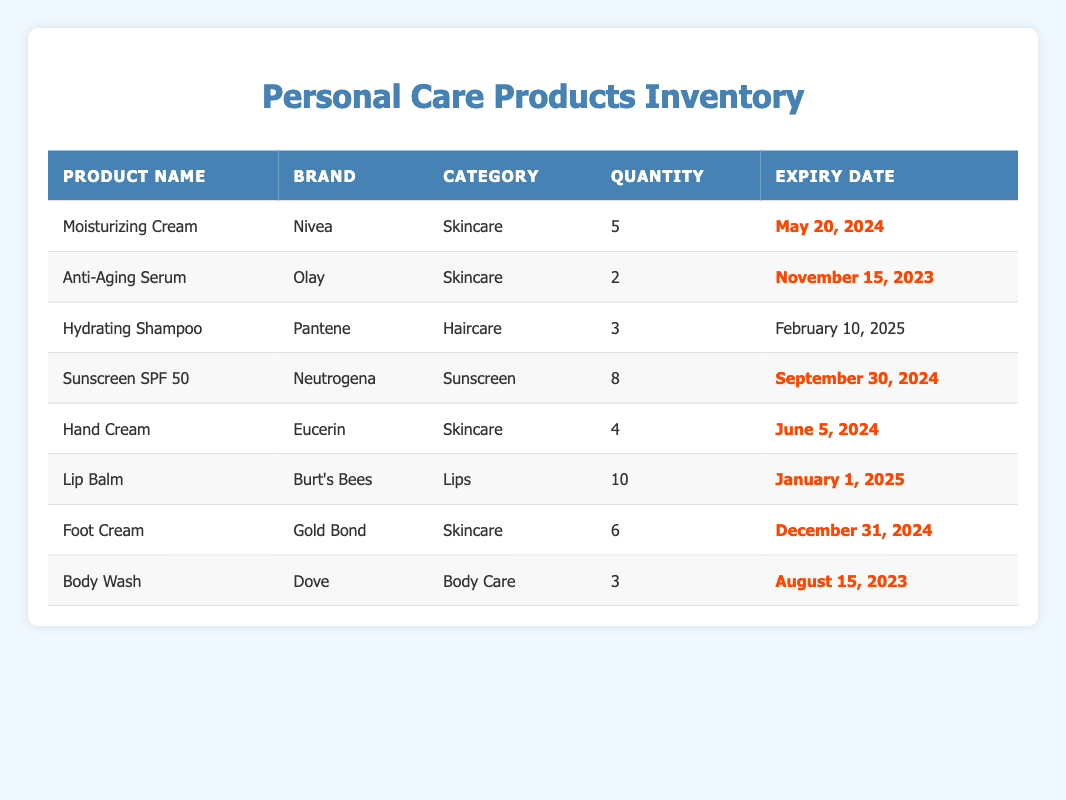What is the expiry date of the Anti-Aging Serum? The expiry date of the Anti-Aging Serum is listed in the table under the "Expiry Date" column for that product. It shows November 15, 2023.
Answer: November 15, 2023 How many Hand Creams are available in the inventory? The quantity of Hand Creams is indicated in the "Quantity" column next to the Hand Cream entry in the table. It shows a quantity of 4.
Answer: 4 Which product has the earliest expiry date? To find the product with the earliest expiry date, we compare the expiry dates of all products listed in the table. The earliest one is for Body Wash, which expires on August 15, 2023.
Answer: Body Wash How many Personal Care products have an expiry date in 2024? We count the number of products that have their expiry dates listed in the year 2024. The products are Moisturizing Cream, Sunscreen SPF 50, Hand Cream, and Foot Cream, adding up to 4 products.
Answer: 4 Does the inventory contain any foot cream? Looking at the "product_name" column in the table, we can check if any products match "Foot Cream." Since there is an entry for Foot Cream, the answer is yes.
Answer: Yes What is the total quantity of skincare products listed in the inventory? To find the total quantity of skincare products, we identify the products in the "Skincare" category and sum their quantities. The Moisturizing Cream has 5, the Anti-Aging Serum has 2, the Hand Cream has 4, and the Foot Cream has 6, totaling 17.
Answer: 17 Is there any product that will expire within the next six months? We need to check each expiry date against today's date to determine if it is less than six months away. The Body Wash expires on August 15, 2023, and the Anti-Aging Serum expires on November 15, 2023, both of which are within six months. Therefore, yes.
Answer: Yes Which brand has the most products in this inventory? By reviewing the "brand" column in the table, we count the number of products associated with each brand. Olay has 1, Nivea has 1, Pantene has 1, Neutrogena has 1, Eucerin has 1, Burt's Bees has 1, Gold Bond has 1, and Dove has 1. All brands have the same quantity of 1 product, so there is no single brand with the most products.
Answer: None 